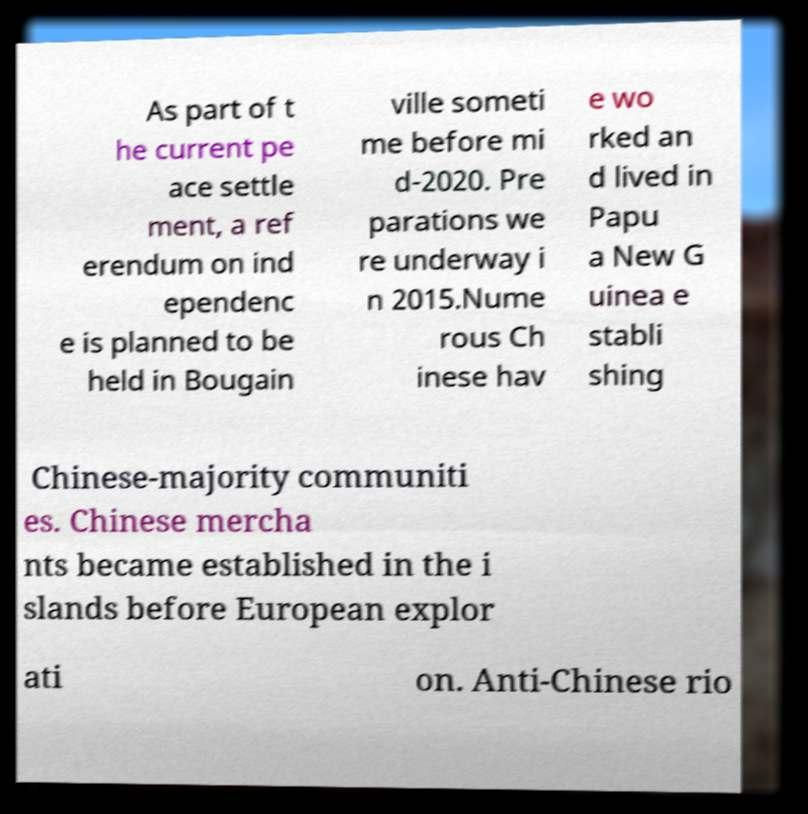For documentation purposes, I need the text within this image transcribed. Could you provide that? As part of t he current pe ace settle ment, a ref erendum on ind ependenc e is planned to be held in Bougain ville someti me before mi d-2020. Pre parations we re underway i n 2015.Nume rous Ch inese hav e wo rked an d lived in Papu a New G uinea e stabli shing Chinese-majority communiti es. Chinese mercha nts became established in the i slands before European explor ati on. Anti-Chinese rio 